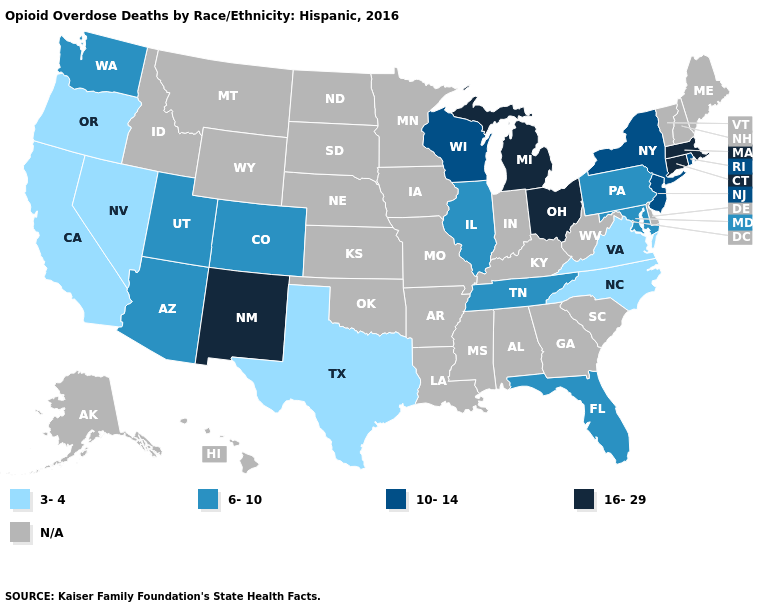What is the value of Connecticut?
Quick response, please. 16-29. Name the states that have a value in the range 16-29?
Keep it brief. Connecticut, Massachusetts, Michigan, New Mexico, Ohio. Is the legend a continuous bar?
Write a very short answer. No. Does Michigan have the highest value in the MidWest?
Write a very short answer. Yes. Does Michigan have the highest value in the USA?
Write a very short answer. Yes. What is the lowest value in the South?
Keep it brief. 3-4. What is the highest value in the South ?
Answer briefly. 6-10. What is the lowest value in states that border Alabama?
Give a very brief answer. 6-10. What is the highest value in states that border Connecticut?
Give a very brief answer. 16-29. Among the states that border North Carolina , which have the highest value?
Write a very short answer. Tennessee. What is the highest value in the MidWest ?
Write a very short answer. 16-29. Name the states that have a value in the range 6-10?
Be succinct. Arizona, Colorado, Florida, Illinois, Maryland, Pennsylvania, Tennessee, Utah, Washington. Which states have the lowest value in the South?
Keep it brief. North Carolina, Texas, Virginia. What is the highest value in states that border Arizona?
Answer briefly. 16-29. 